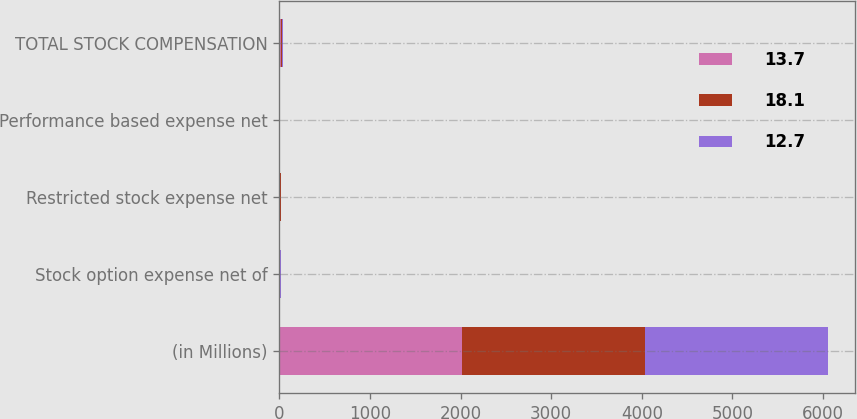Convert chart to OTSL. <chart><loc_0><loc_0><loc_500><loc_500><stacked_bar_chart><ecel><fcel>(in Millions)<fcel>Stock option expense net of<fcel>Restricted stock expense net<fcel>Performance based expense net<fcel>TOTAL STOCK COMPENSATION<nl><fcel>13.7<fcel>2018<fcel>4.9<fcel>8.4<fcel>4.4<fcel>18.1<nl><fcel>18.1<fcel>2017<fcel>4.5<fcel>6.4<fcel>2.8<fcel>13.7<nl><fcel>12.7<fcel>2016<fcel>4.4<fcel>6.5<fcel>1.8<fcel>12.7<nl></chart> 